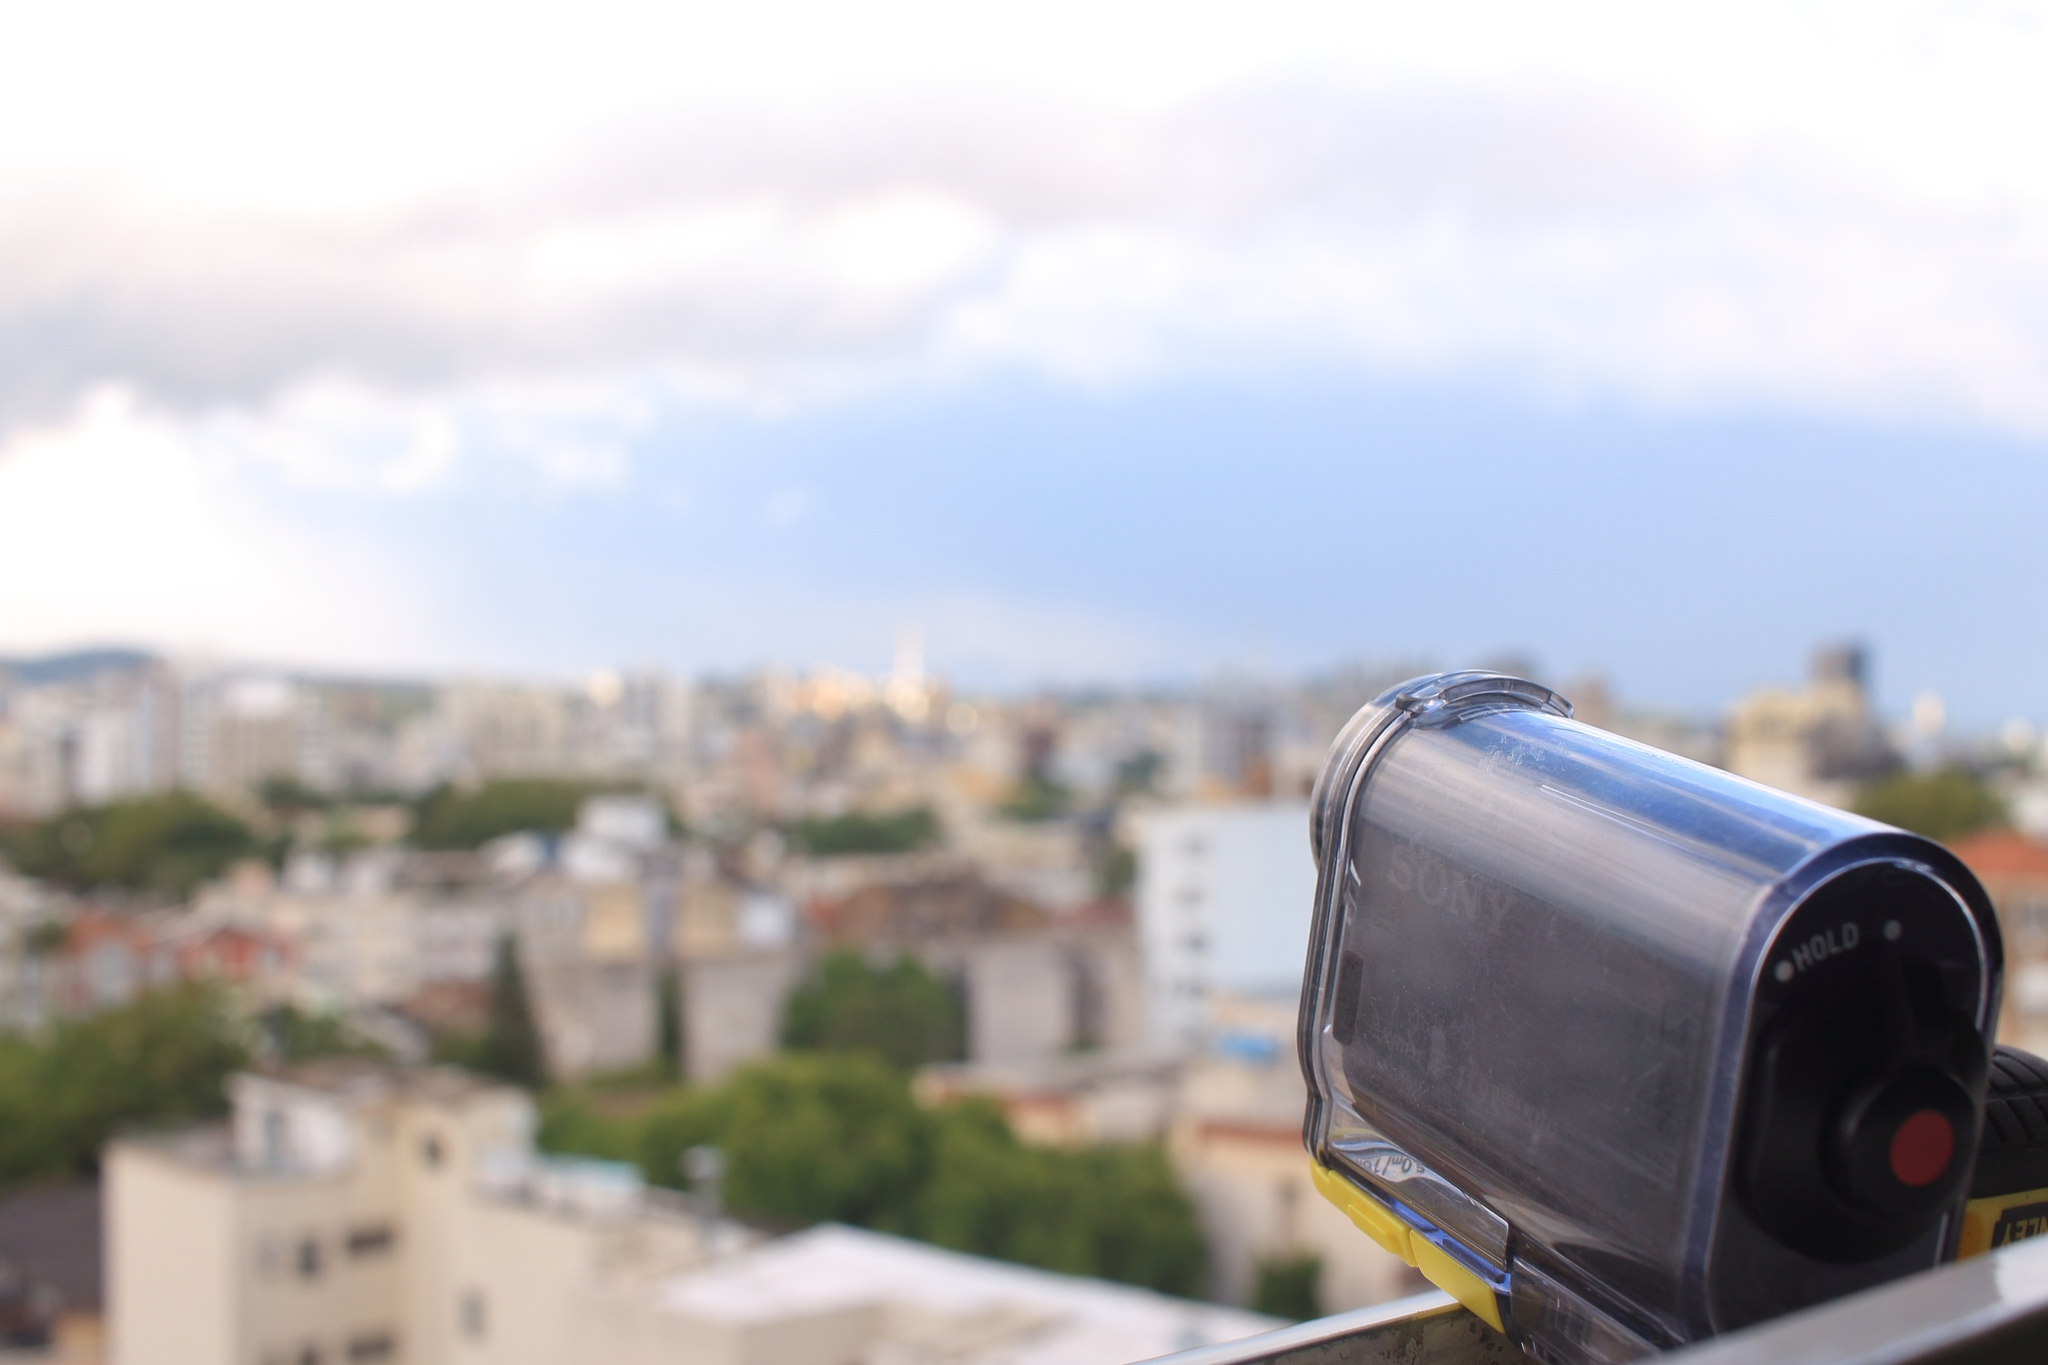Could you describe the weather in the scene? The weather in the scene appears to be quite pleasant. The sky is a clear blue with a few scattered, fluffy white clouds suggesting a bright and sunny day. The visibility is good, and the gentle clouds indicate calm weather conditions, perfect for a day of photography or exploring the city. 